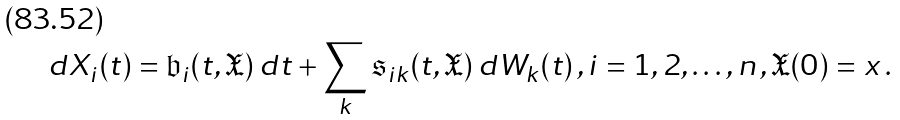Convert formula to latex. <formula><loc_0><loc_0><loc_500><loc_500>d X _ { i } ( t ) = \mathfrak { b } _ { i } ( t , \mathfrak { X } ) \, d t + \sum _ { k } \mathfrak { s } _ { i k } ( t , \mathfrak { X } ) \, d W _ { k } ( t ) \, , i = 1 , 2 , \dots , n \, , \mathfrak { X } ( 0 ) = x \, .</formula> 